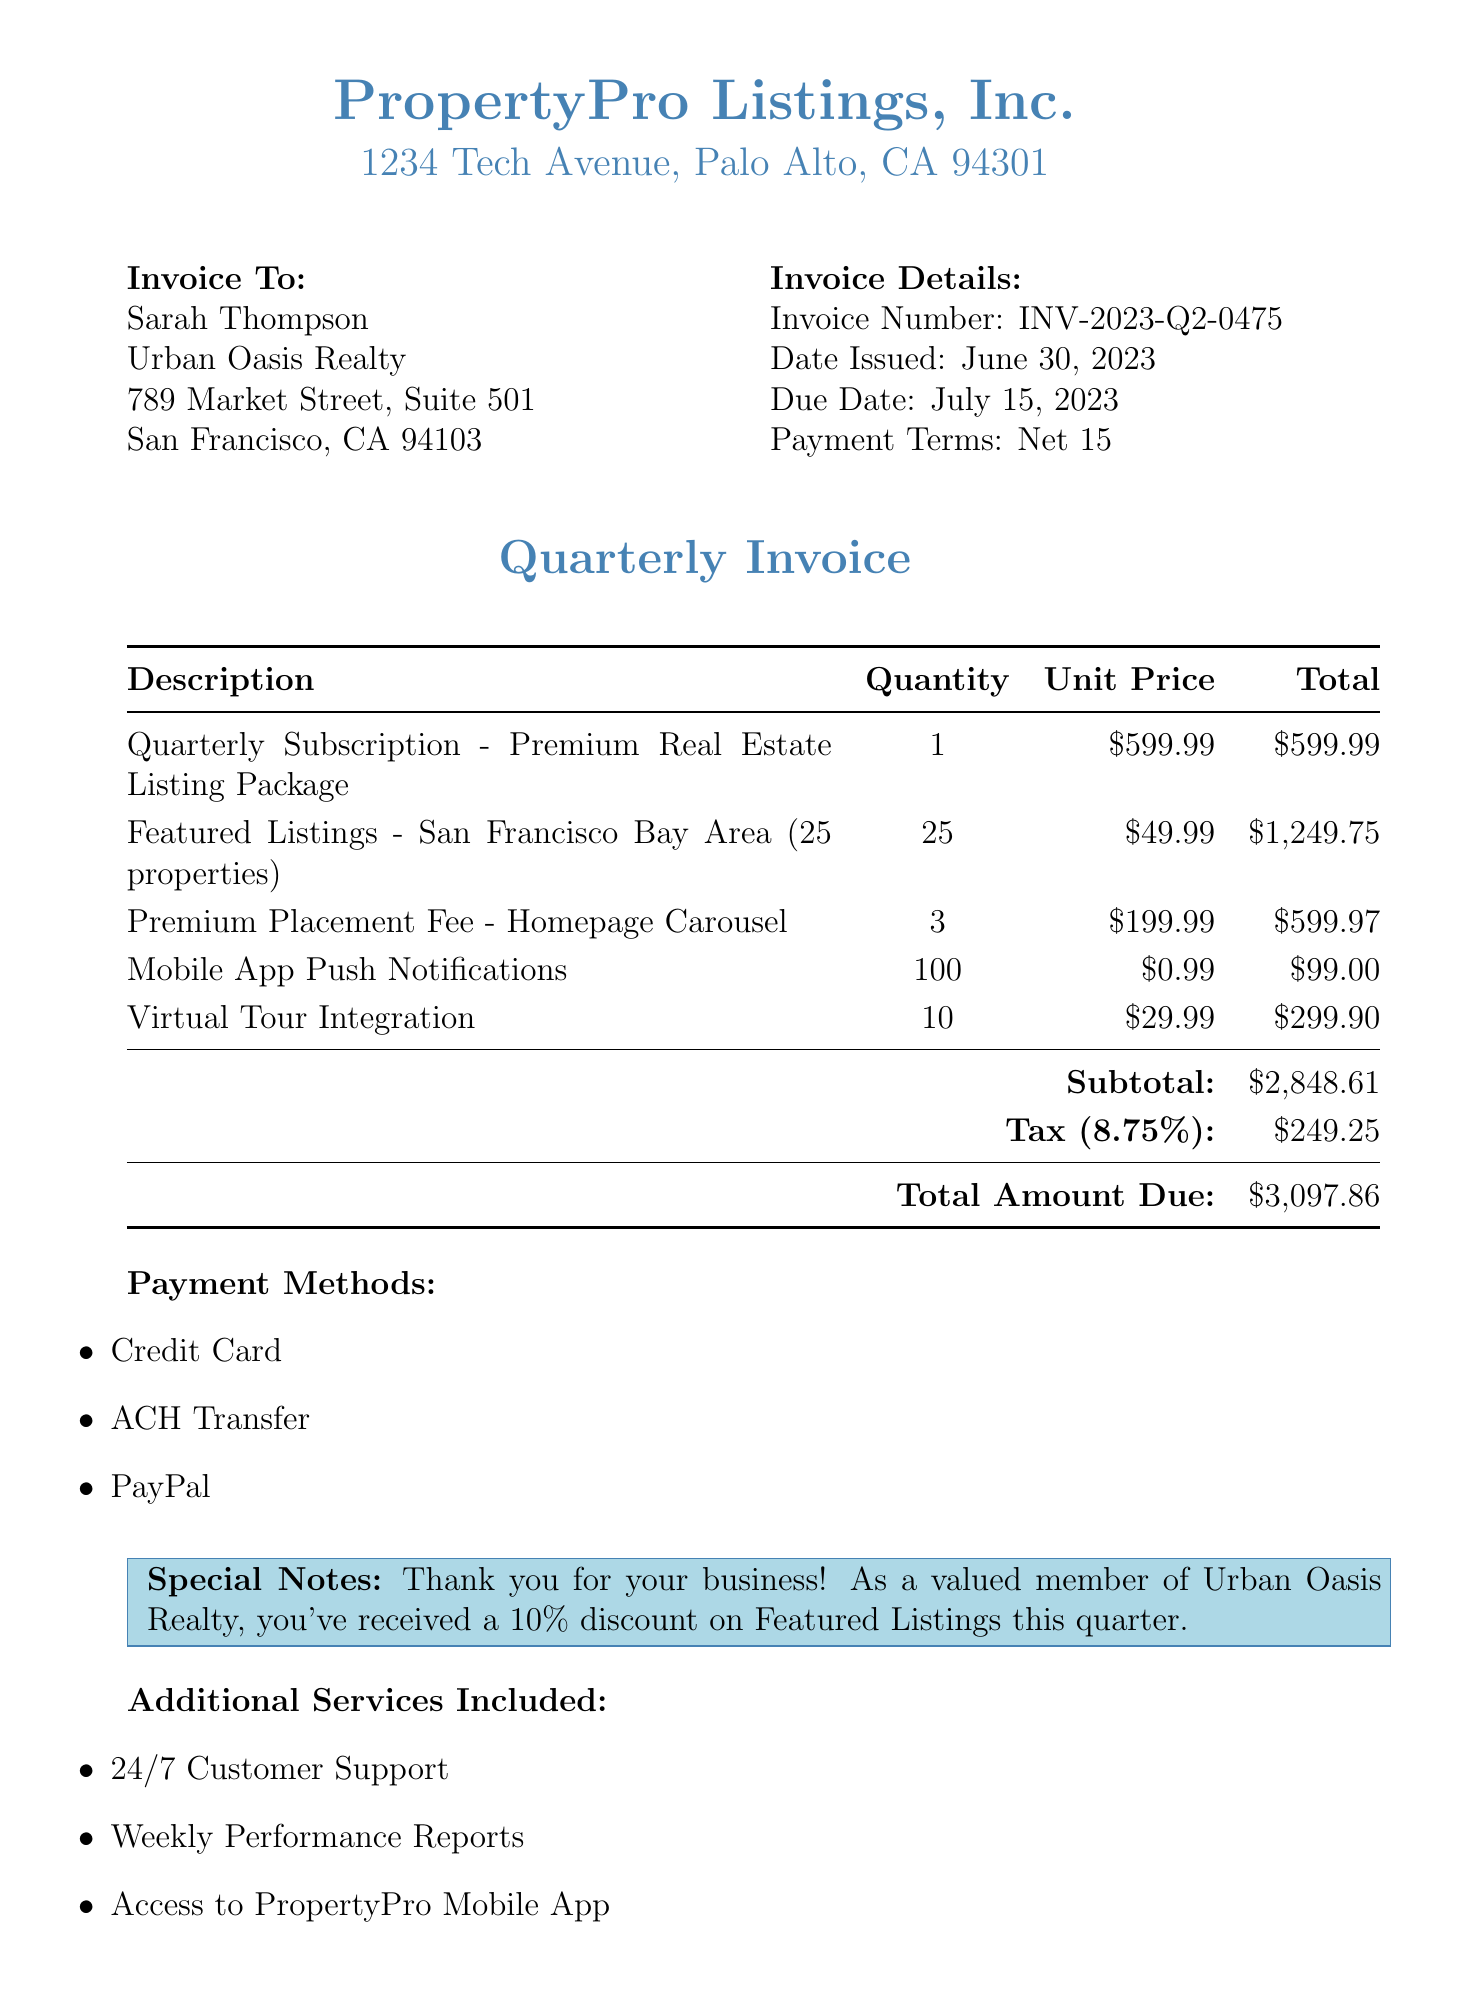what is the invoice number? The invoice number is displayed prominently at the top of the document, identified as INV-2023-Q2-0475.
Answer: INV-2023-Q2-0475 who is the client company? The client company is listed next to the client name and is Urban Oasis Realty.
Answer: Urban Oasis Realty what is the total amount due? The total amount due is clearly stated in the invoice summary section as $3,097.86.
Answer: $3,097.86 what is the due date for payment? The due date for payment is provided in the invoice details as July 15, 2023.
Answer: July 15, 2023 how much was charged for the Mobile App Push Notifications? The document specifies the charge for Mobile App Push Notifications as $99.00 for 100 notifications.
Answer: $99.00 how many properties are included in the Featured Listings? The number of properties included in the Featured Listings is stated as 25.
Answer: 25 what discount was received on Featured Listings? A special note indicates that a 10% discount was received on Featured Listings this quarter.
Answer: 10% who is the account manager? The account manager's name is listed at the bottom of the document, which is Michael Chen.
Answer: Michael Chen what payment terms are specified in the invoice? The payment terms are described as Net 15 in the invoice details.
Answer: Net 15 